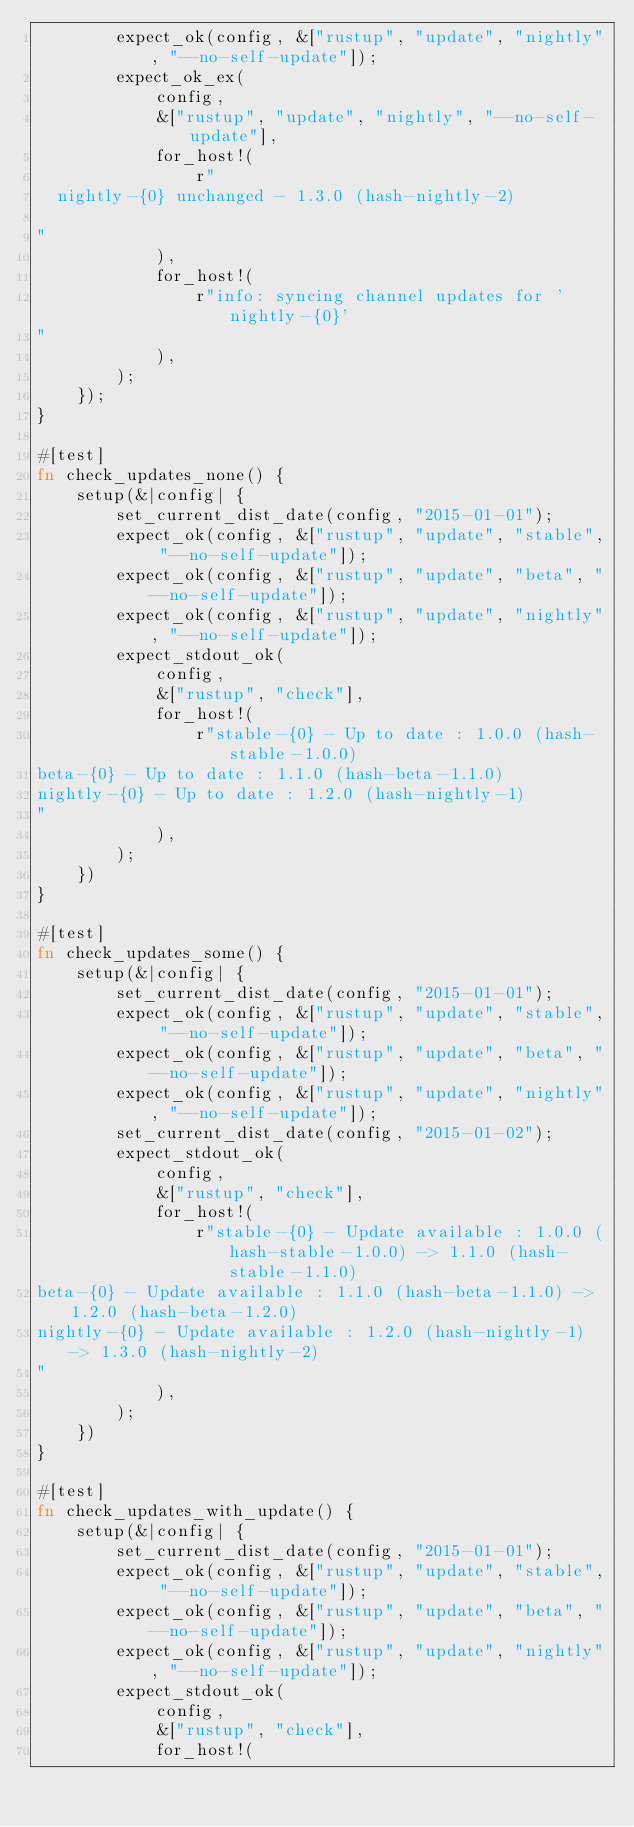<code> <loc_0><loc_0><loc_500><loc_500><_Rust_>        expect_ok(config, &["rustup", "update", "nightly", "--no-self-update"]);
        expect_ok_ex(
            config,
            &["rustup", "update", "nightly", "--no-self-update"],
            for_host!(
                r"
  nightly-{0} unchanged - 1.3.0 (hash-nightly-2)

"
            ),
            for_host!(
                r"info: syncing channel updates for 'nightly-{0}'
"
            ),
        );
    });
}

#[test]
fn check_updates_none() {
    setup(&|config| {
        set_current_dist_date(config, "2015-01-01");
        expect_ok(config, &["rustup", "update", "stable", "--no-self-update"]);
        expect_ok(config, &["rustup", "update", "beta", "--no-self-update"]);
        expect_ok(config, &["rustup", "update", "nightly", "--no-self-update"]);
        expect_stdout_ok(
            config,
            &["rustup", "check"],
            for_host!(
                r"stable-{0} - Up to date : 1.0.0 (hash-stable-1.0.0)
beta-{0} - Up to date : 1.1.0 (hash-beta-1.1.0)
nightly-{0} - Up to date : 1.2.0 (hash-nightly-1)
"
            ),
        );
    })
}

#[test]
fn check_updates_some() {
    setup(&|config| {
        set_current_dist_date(config, "2015-01-01");
        expect_ok(config, &["rustup", "update", "stable", "--no-self-update"]);
        expect_ok(config, &["rustup", "update", "beta", "--no-self-update"]);
        expect_ok(config, &["rustup", "update", "nightly", "--no-self-update"]);
        set_current_dist_date(config, "2015-01-02");
        expect_stdout_ok(
            config,
            &["rustup", "check"],
            for_host!(
                r"stable-{0} - Update available : 1.0.0 (hash-stable-1.0.0) -> 1.1.0 (hash-stable-1.1.0)
beta-{0} - Update available : 1.1.0 (hash-beta-1.1.0) -> 1.2.0 (hash-beta-1.2.0)
nightly-{0} - Update available : 1.2.0 (hash-nightly-1) -> 1.3.0 (hash-nightly-2)
"
            ),
        );
    })
}

#[test]
fn check_updates_with_update() {
    setup(&|config| {
        set_current_dist_date(config, "2015-01-01");
        expect_ok(config, &["rustup", "update", "stable", "--no-self-update"]);
        expect_ok(config, &["rustup", "update", "beta", "--no-self-update"]);
        expect_ok(config, &["rustup", "update", "nightly", "--no-self-update"]);
        expect_stdout_ok(
            config,
            &["rustup", "check"],
            for_host!(</code> 